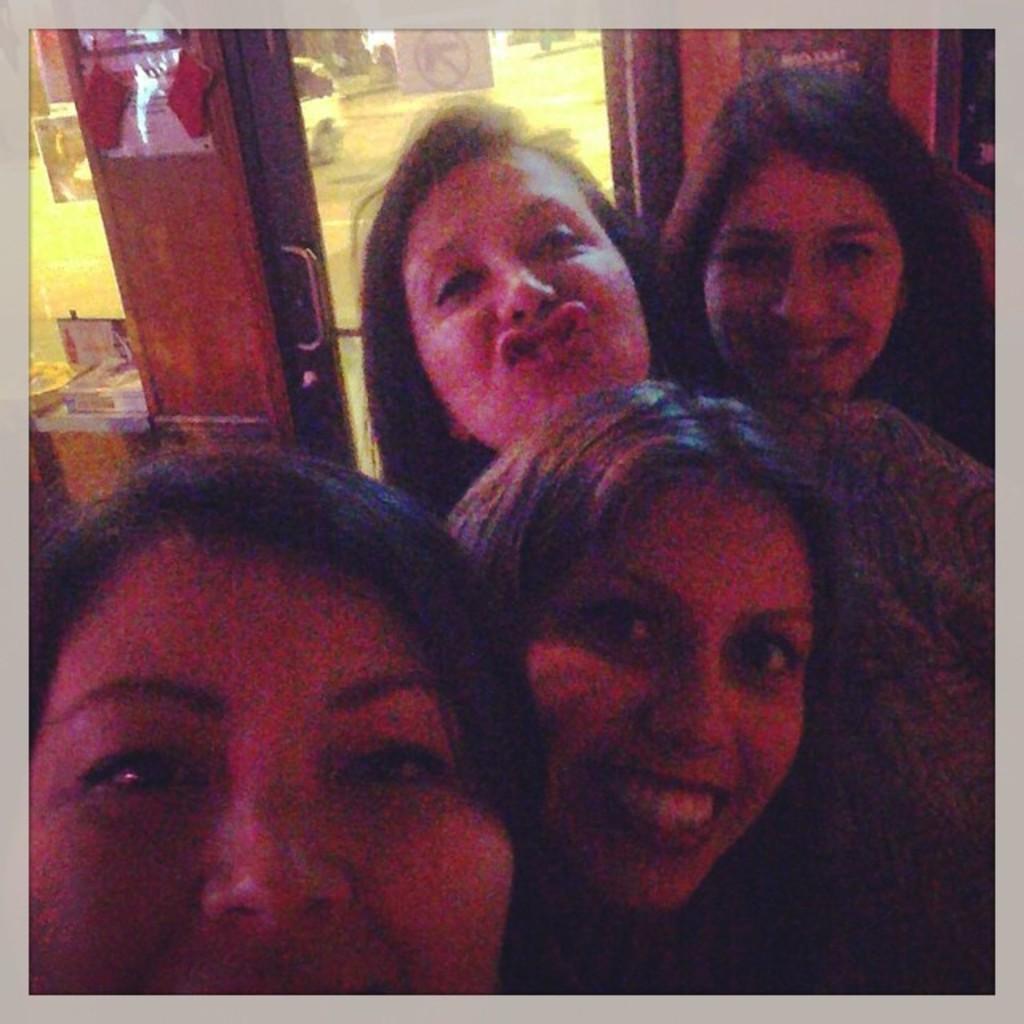Please provide a concise description of this image. In this image there are four women towards the bottom of the image, there is a door, there is a paper on the door, there is a wall, there are objects on the wall, there is a road, there is a car on the road. 